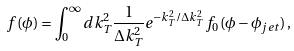Convert formula to latex. <formula><loc_0><loc_0><loc_500><loc_500>f ( \phi ) = \int _ { 0 } ^ { \infty } d k _ { T } ^ { 2 } \frac { 1 } { \Delta k _ { T } ^ { 2 } } e ^ { - k _ { T } ^ { 2 } / \Delta k _ { T } ^ { 2 } } f _ { 0 } ( \phi - \phi _ { j e t } ) \, ,</formula> 